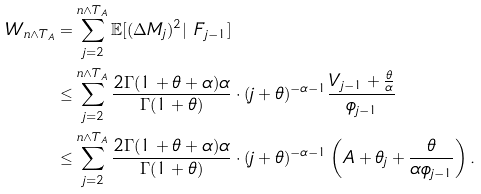Convert formula to latex. <formula><loc_0><loc_0><loc_500><loc_500>W _ { n \wedge T _ { A } } & = \sum _ { j = 2 } ^ { n \wedge T _ { A } } \mathbb { E } [ ( \Delta M _ { j } ) ^ { 2 } | \ F _ { j - 1 } ] \\ & \leq \sum _ { j = 2 } ^ { n \wedge T _ { A } } \frac { 2 \Gamma ( 1 + \theta + \alpha ) \alpha } { \Gamma ( 1 + \theta ) } \cdot ( j + \theta ) ^ { - \alpha - 1 } \frac { V _ { j - 1 } + \frac { \theta } { \alpha } } { \phi _ { j - 1 } } \\ & \leq \sum _ { j = 2 } ^ { n \wedge T _ { A } } \frac { 2 \Gamma ( 1 + \theta + \alpha ) \alpha } { \Gamma ( 1 + \theta ) } \cdot ( j + \theta ) ^ { - \alpha - 1 } \left ( A + \theta _ { j } + \frac { \theta } { \alpha \phi _ { j - 1 } } \right ) .</formula> 